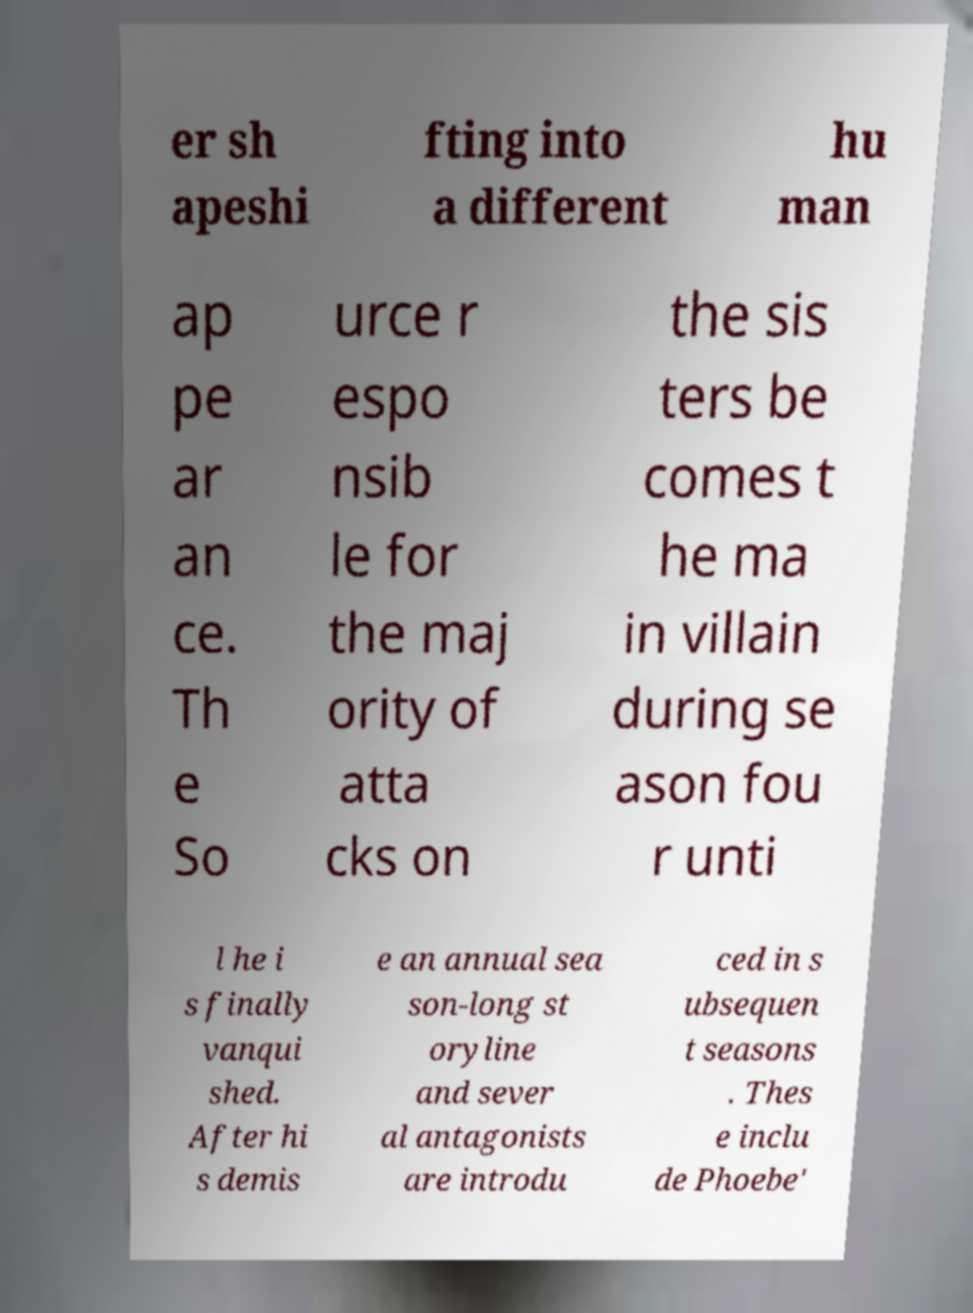Please read and relay the text visible in this image. What does it say? er sh apeshi fting into a different hu man ap pe ar an ce. Th e So urce r espo nsib le for the maj ority of atta cks on the sis ters be comes t he ma in villain during se ason fou r unti l he i s finally vanqui shed. After hi s demis e an annual sea son-long st oryline and sever al antagonists are introdu ced in s ubsequen t seasons . Thes e inclu de Phoebe' 